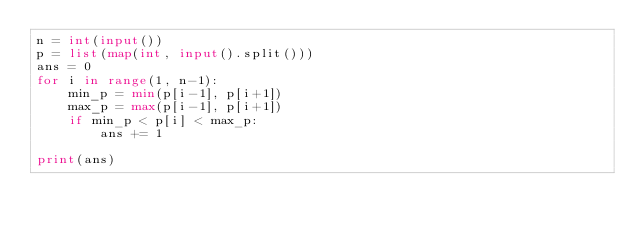<code> <loc_0><loc_0><loc_500><loc_500><_Python_>n = int(input())
p = list(map(int, input().split()))
ans = 0
for i in range(1, n-1):
    min_p = min(p[i-1], p[i+1])
    max_p = max(p[i-1], p[i+1])
    if min_p < p[i] < max_p:
        ans += 1

print(ans)</code> 